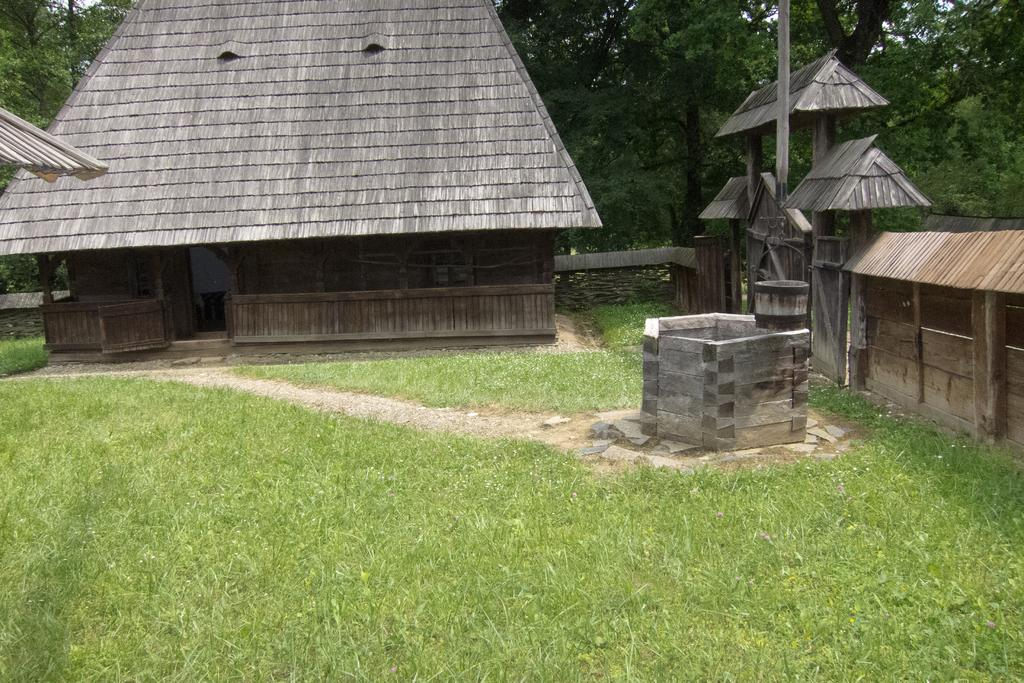What is the main subject in the middle of the image? There is a house in the middle of the image. What type of ground is visible in the image? There is grass on the ground. What can be seen in the background of the image? There are trees in the background of the image. What type of lamp is hanging from the head of the house in the image? There is no lamp or head present in the image; it features a house with grass on the ground and trees in the background. 